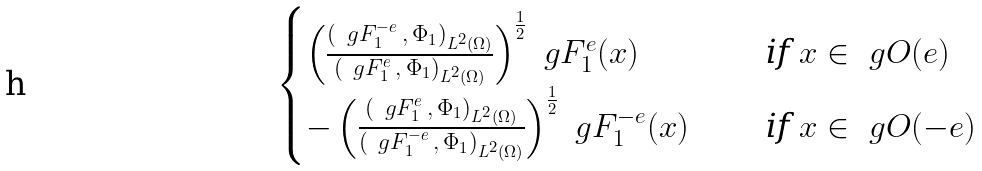<formula> <loc_0><loc_0><loc_500><loc_500>\begin{cases} \left ( \frac { ( \ g F _ { 1 } ^ { - e } \, , \, \Phi _ { 1 } ) _ { L ^ { 2 } ( \Omega ) } } { ( \ g F _ { 1 } ^ { e } \, , \, \Phi _ { 1 } ) _ { L ^ { 2 } ( \Omega ) } } \right ) ^ { \frac { 1 } { 2 } } \ g F _ { 1 } ^ { e } ( x ) \quad & \text { if } x \in \ g O ( e ) \\ - \left ( \frac { ( \ g F _ { 1 } ^ { e } \, , \, \Phi _ { 1 } ) _ { L ^ { 2 } ( \Omega ) } } { ( \ g F _ { 1 } ^ { - e } \, , \, \Phi _ { 1 } ) _ { L ^ { 2 } ( \Omega ) } } \right ) ^ { \frac { 1 } { 2 } } \ g F _ { 1 } ^ { - e } ( x ) \quad & \text { if } x \in \ g O ( - e ) \end{cases}</formula> 